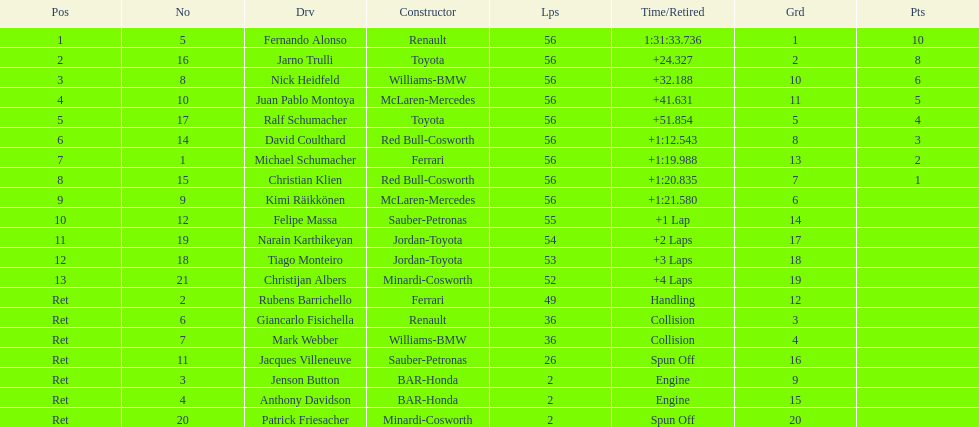How many drivers finished the race prematurely due to engine issues? 2. 